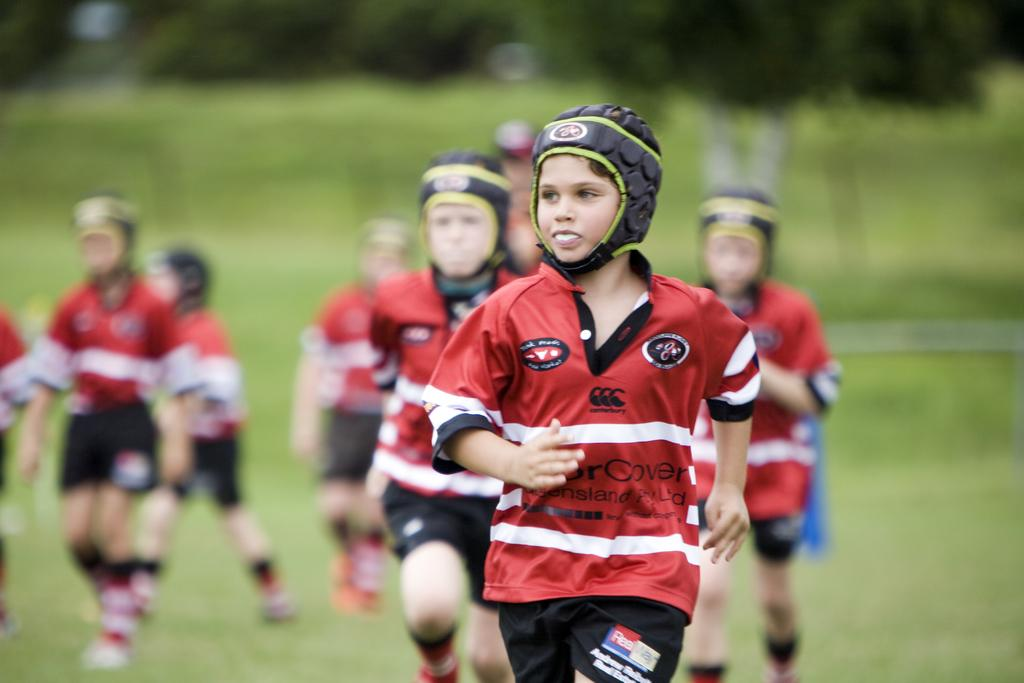What is the main subject of the image? The main subject of the image is a group of kids. What are the kids doing in the image? The kids are running on the ground in the image. What color are the dresses worn by the kids? The kids are wearing red color dresses. What protective gear are the kids wearing? The kids are wearing black color helmets. What can be seen in the background of the image? There are trees in the background of the image. What type of surface are the kids running on? There is grass on the ground in the image. What basketball team are the kids playing for in the image? There is no basketball team or game present in the image; the kids are simply running. What joke is the servant telling the kids in the image? There is no servant or joke present in the image; the focus is on the kids running. 